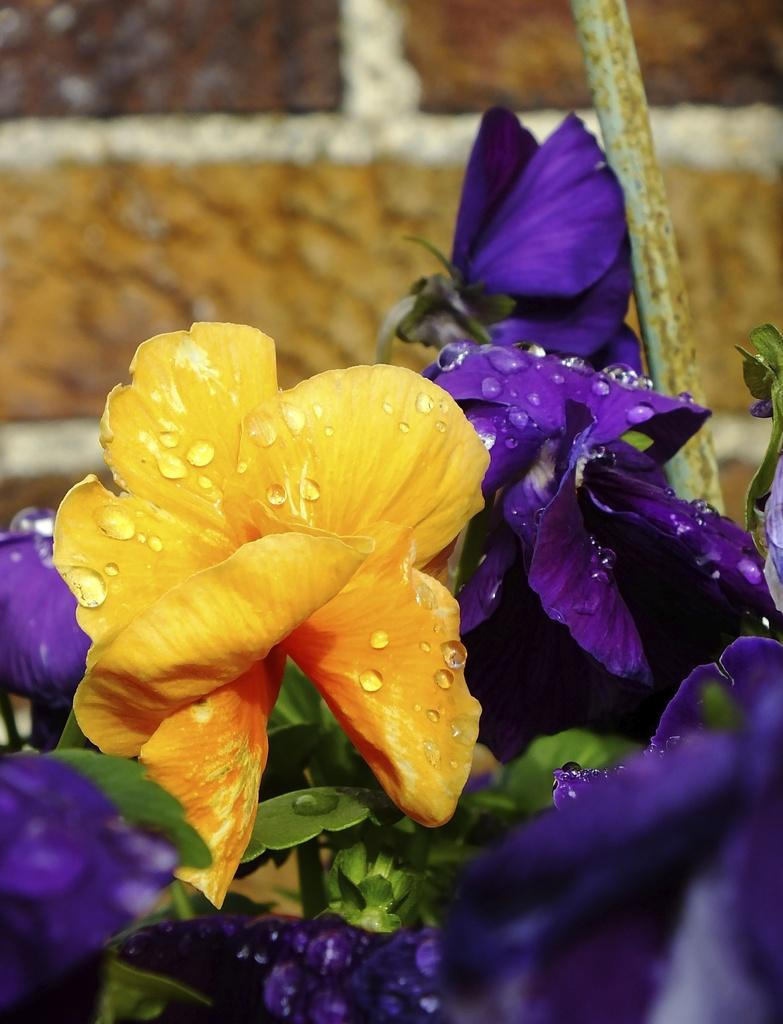What type of plants can be seen in the image? There are flowers in the image. What colors are the flowers? The flowers are yellow and violet in color. What object is located on the right side of the image? There is an iron rod on the right side of the image. How would you describe the background of the image? The background of the image is blurred. How many feet are visible in the image? There are no feet visible in the image. What type of crack can be seen in the image? There is no crack present in the image. 